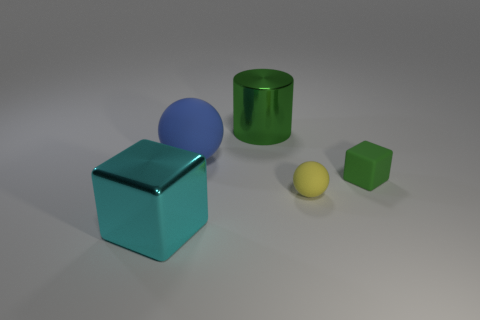Add 5 big brown cubes. How many objects exist? 10 Subtract all cyan cubes. How many cubes are left? 1 Subtract all cylinders. How many objects are left? 4 Subtract all red balls. Subtract all yellow cylinders. How many balls are left? 2 Add 1 brown rubber spheres. How many brown rubber spheres exist? 1 Subtract 1 green cylinders. How many objects are left? 4 Subtract all blue rubber spheres. Subtract all large brown rubber spheres. How many objects are left? 4 Add 2 balls. How many balls are left? 4 